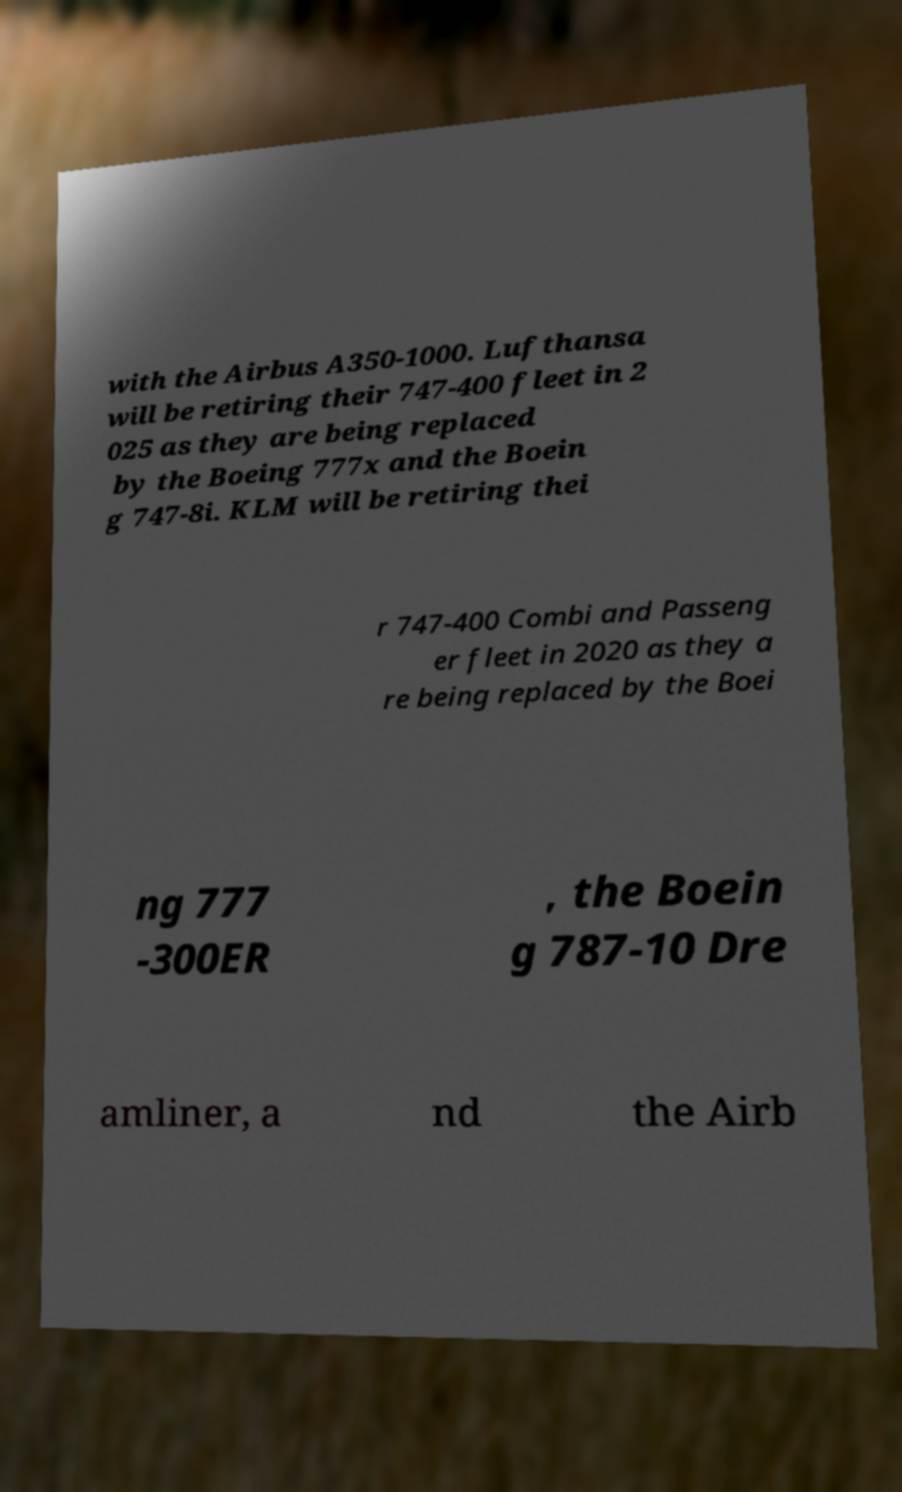Can you accurately transcribe the text from the provided image for me? with the Airbus A350-1000. Lufthansa will be retiring their 747-400 fleet in 2 025 as they are being replaced by the Boeing 777x and the Boein g 747-8i. KLM will be retiring thei r 747-400 Combi and Passeng er fleet in 2020 as they a re being replaced by the Boei ng 777 -300ER , the Boein g 787-10 Dre amliner, a nd the Airb 